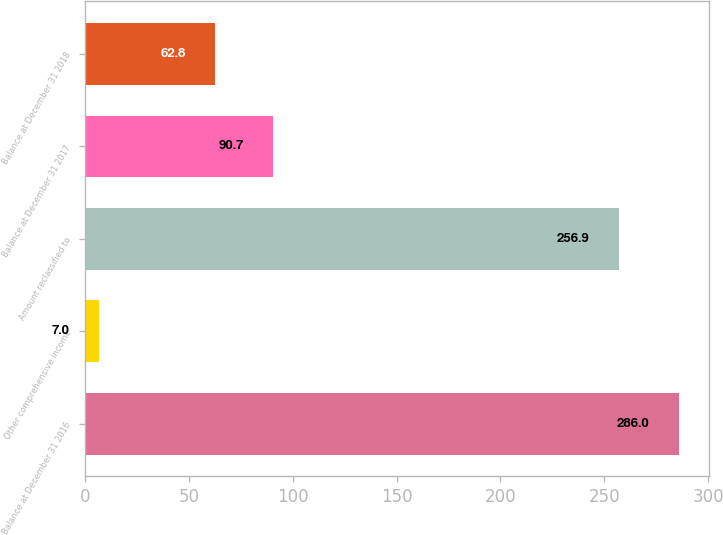<chart> <loc_0><loc_0><loc_500><loc_500><bar_chart><fcel>Balance at December 31 2016<fcel>Other comprehensive income<fcel>Amount reclassified to<fcel>Balance at December 31 2017<fcel>Balance at December 31 2018<nl><fcel>286<fcel>7<fcel>256.9<fcel>90.7<fcel>62.8<nl></chart> 